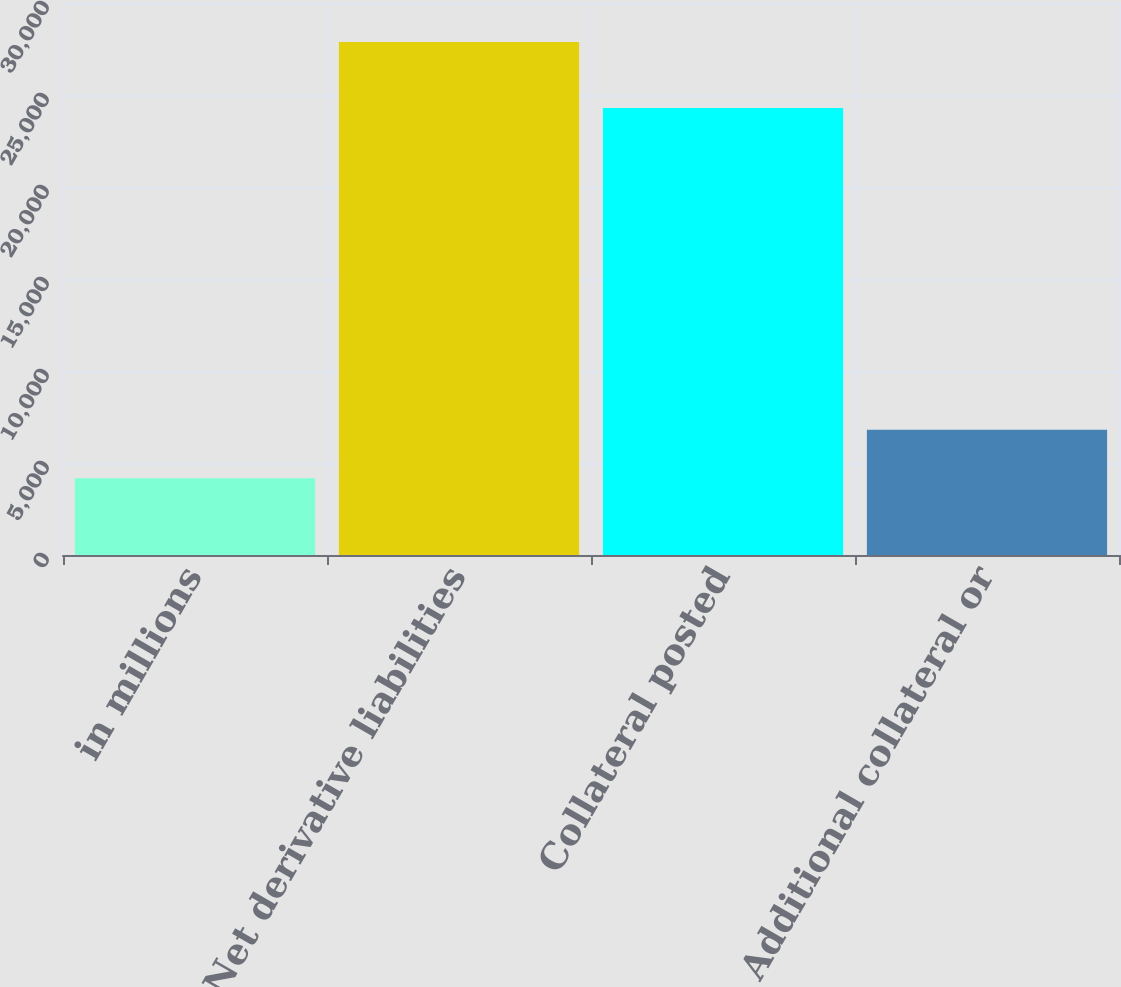Convert chart to OTSL. <chart><loc_0><loc_0><loc_500><loc_500><bar_chart><fcel>in millions<fcel>Net derivative liabilities<fcel>Collateral posted<fcel>Additional collateral or<nl><fcel>4169.1<fcel>27885<fcel>24296<fcel>6804.2<nl></chart> 